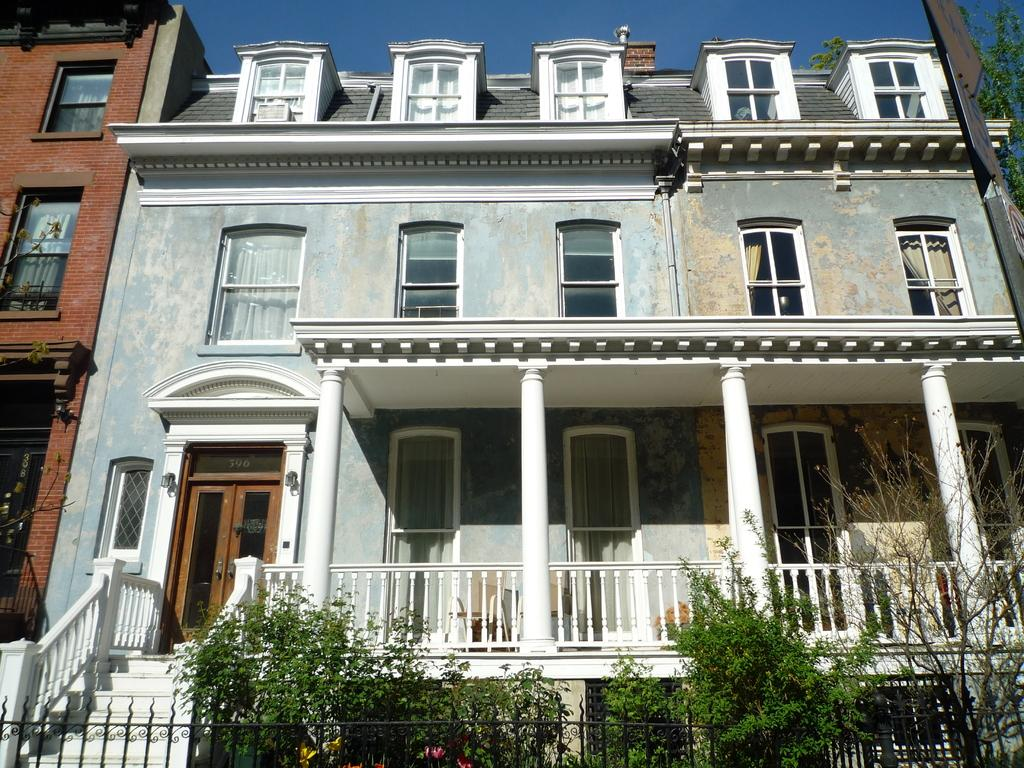What type of vegetation is at the bottom of the image? There are trees at the bottom of the image. What type of structure is present in the image? There is a building in the image. What is visible at the top of the image? The sky is visible at the top of the image. Can you see the cat's ear in the image? There is no cat or ear present in the image. What time of day is it in the image? The time of day is not mentioned in the image, so it cannot be determined. 